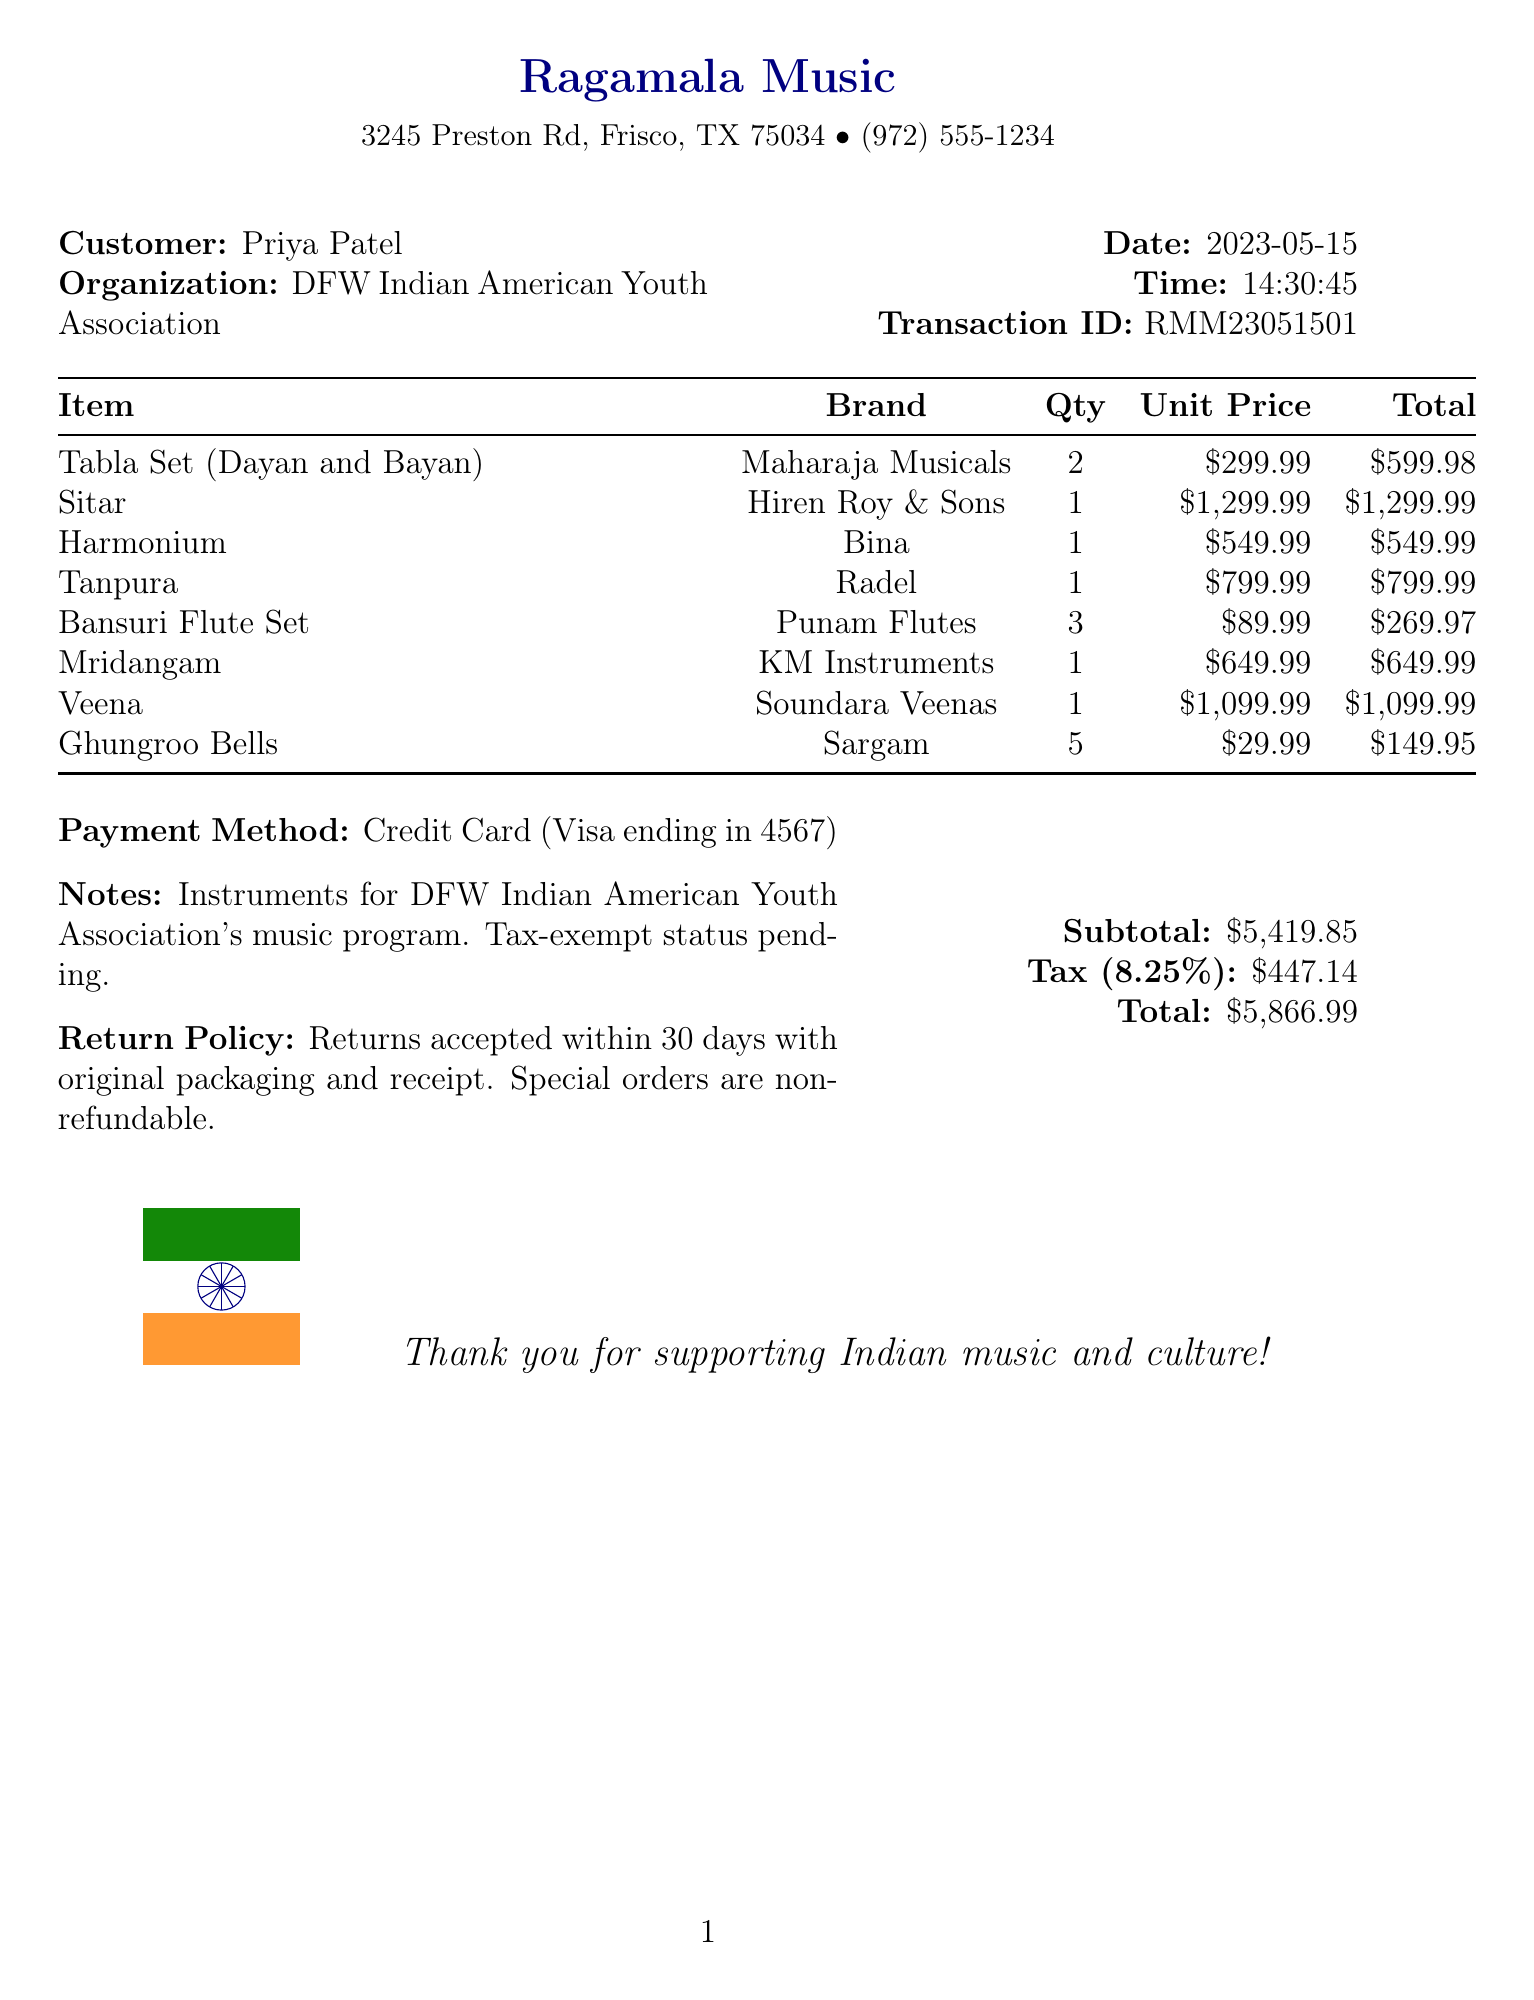what is the name of the store? The store name is mentioned in the header of the receipt as Ragamala Music.
Answer: Ragamala Music who is the customer? The customer name is listed under the customer information section as Priya Patel.
Answer: Priya Patel what is the transaction ID? The transaction ID is provided in the document as RMM23051501.
Answer: RMM23051501 how many Ghungroo Bells were purchased? The quantity of Ghungroo Bells is stated in the itemized list as 5.
Answer: 5 what is the total amount spent? The total amount is calculated and presented at the end of the document as $5,866.99.
Answer: $5,866.99 what is the tax rate? The document specifies the tax rate applied as 8.25%.
Answer: 8.25% which instrument was purchased the most in quantity? The instrument purchased in the highest quantity is Bansuri Flute Set, with a quantity of 3.
Answer: Bansuri Flute Set what is the return policy for the purchased instruments? The return policy is included in the receipt stating that returns are accepted within 30 days with original packaging and receipt.
Answer: Returns accepted within 30 days with original packaging and receipt what payment method was used for the transaction? The payment method is stated at the bottom of the receipt as Credit Card (Visa ending in 4567).
Answer: Credit Card (Visa ending in 4567) what is the customer's organization? The customer's organization is identified in the document as DFW Indian American Youth Association.
Answer: DFW Indian American Youth Association 